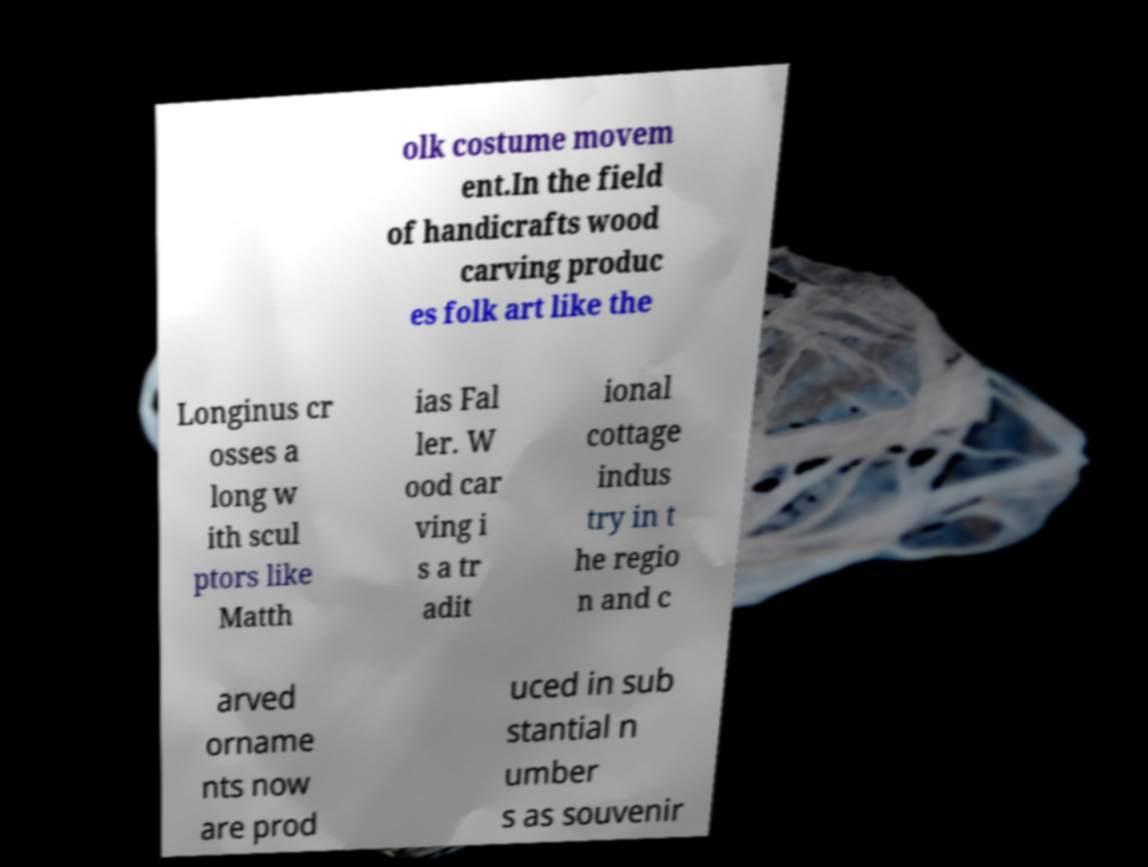Can you read and provide the text displayed in the image?This photo seems to have some interesting text. Can you extract and type it out for me? olk costume movem ent.In the field of handicrafts wood carving produc es folk art like the Longinus cr osses a long w ith scul ptors like Matth ias Fal ler. W ood car ving i s a tr adit ional cottage indus try in t he regio n and c arved orname nts now are prod uced in sub stantial n umber s as souvenir 